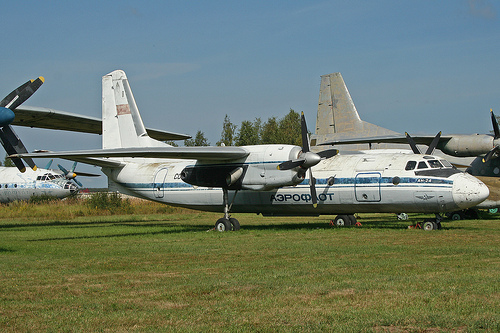<image>
Can you confirm if the airplane is on the ground? Yes. Looking at the image, I can see the airplane is positioned on top of the ground, with the ground providing support. 